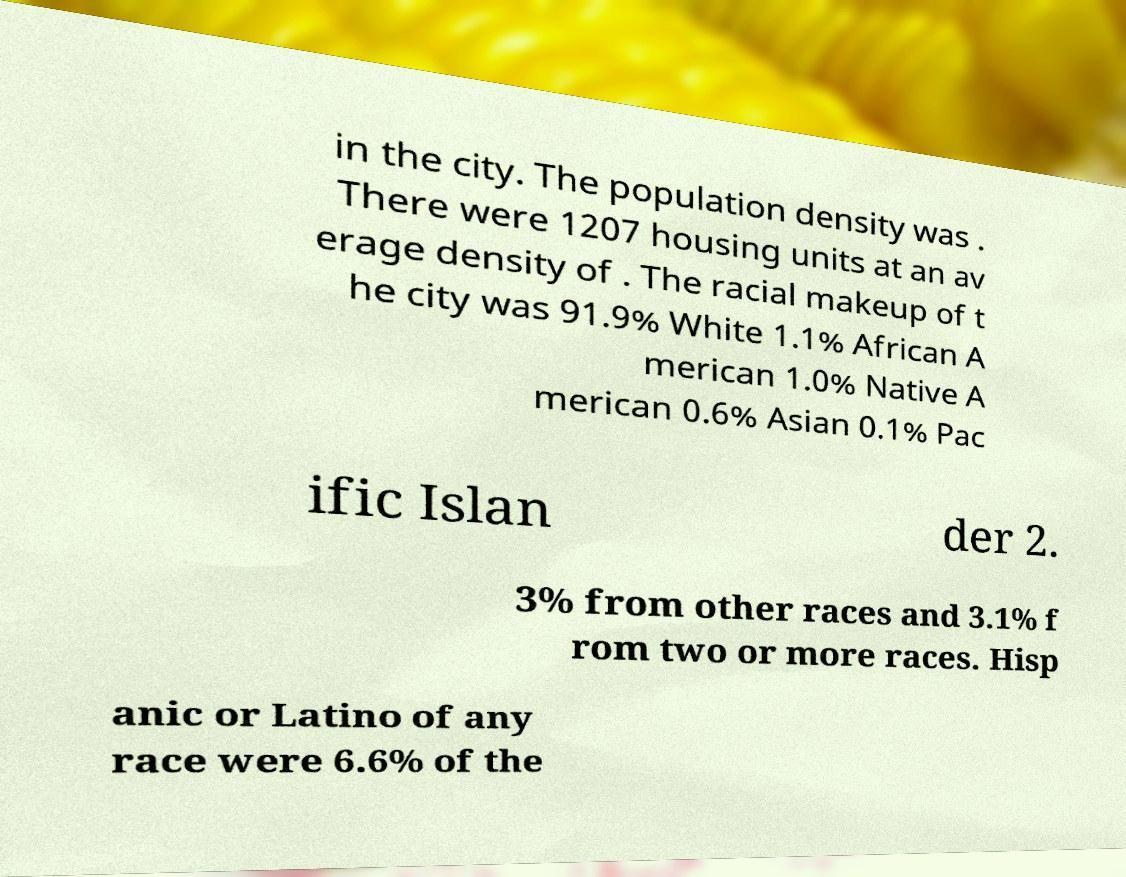Could you assist in decoding the text presented in this image and type it out clearly? in the city. The population density was . There were 1207 housing units at an av erage density of . The racial makeup of t he city was 91.9% White 1.1% African A merican 1.0% Native A merican 0.6% Asian 0.1% Pac ific Islan der 2. 3% from other races and 3.1% f rom two or more races. Hisp anic or Latino of any race were 6.6% of the 